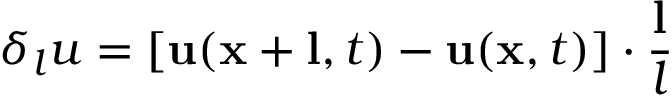Convert formula to latex. <formula><loc_0><loc_0><loc_500><loc_500>\delta _ { l } u = \left [ u ( x + l , t ) - u ( x , t ) \right ] \cdot \frac { l } { l }</formula> 